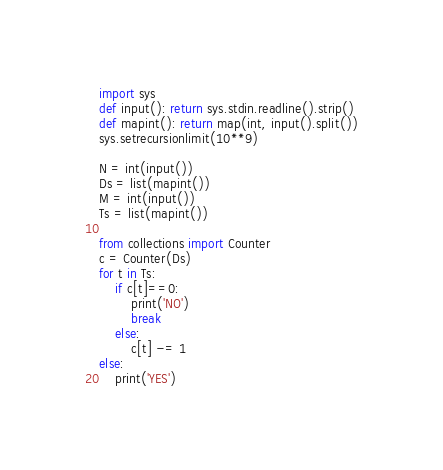Convert code to text. <code><loc_0><loc_0><loc_500><loc_500><_Python_>import sys
def input(): return sys.stdin.readline().strip()
def mapint(): return map(int, input().split())
sys.setrecursionlimit(10**9)

N = int(input())
Ds = list(mapint())
M = int(input())
Ts = list(mapint())

from collections import Counter
c = Counter(Ds)
for t in Ts:
    if c[t]==0:
        print('NO')
        break
    else:
        c[t] -= 1
else:
    print('YES')</code> 